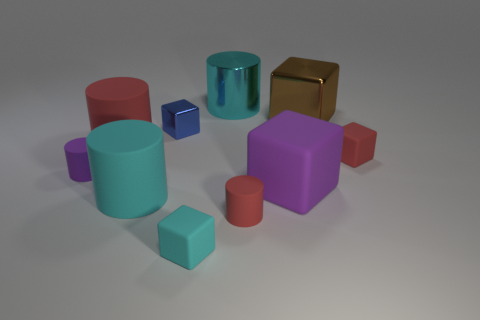Subtract all rubber cylinders. How many cylinders are left? 1 Subtract all purple cubes. How many cubes are left? 4 Subtract 1 blue blocks. How many objects are left? 9 Subtract 1 cylinders. How many cylinders are left? 4 Subtract all purple blocks. Subtract all green spheres. How many blocks are left? 4 Subtract all purple cylinders. How many brown blocks are left? 1 Subtract all tiny green things. Subtract all cyan blocks. How many objects are left? 9 Add 3 big metal objects. How many big metal objects are left? 5 Add 2 big purple metallic spheres. How many big purple metallic spheres exist? 2 